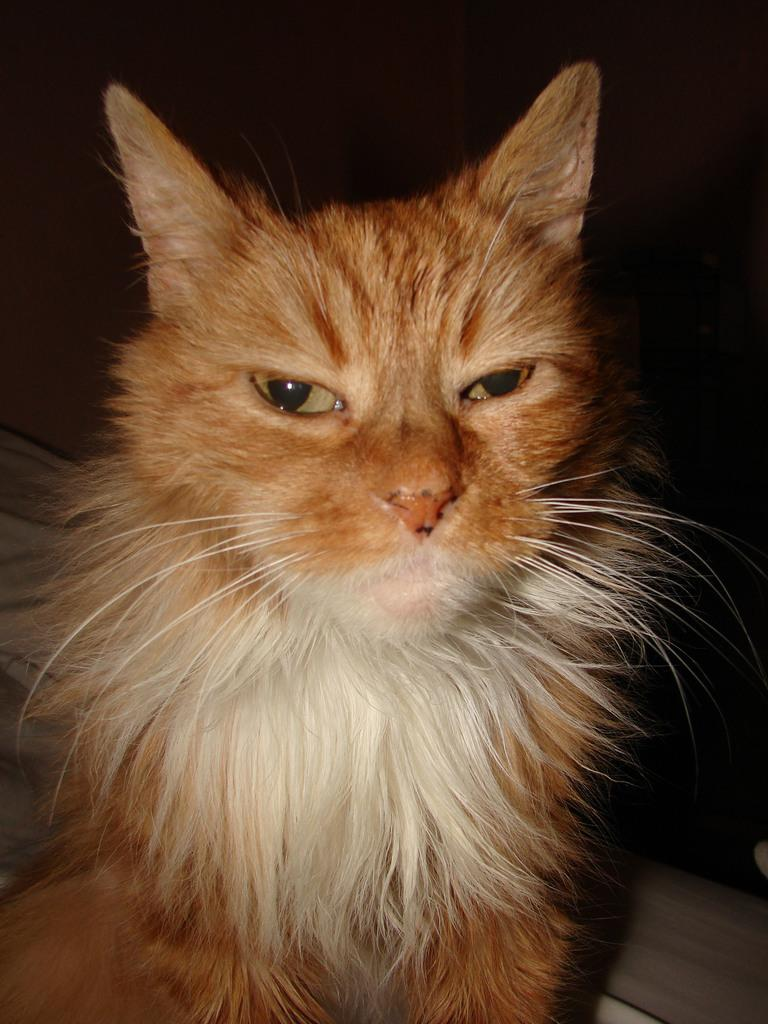What type of animal is present in the image? There is a cat in the image. How many cats are being transported in the cat's pocket in the image? There is no mention of a pocket or transportation in the image, and there is only one cat present. 